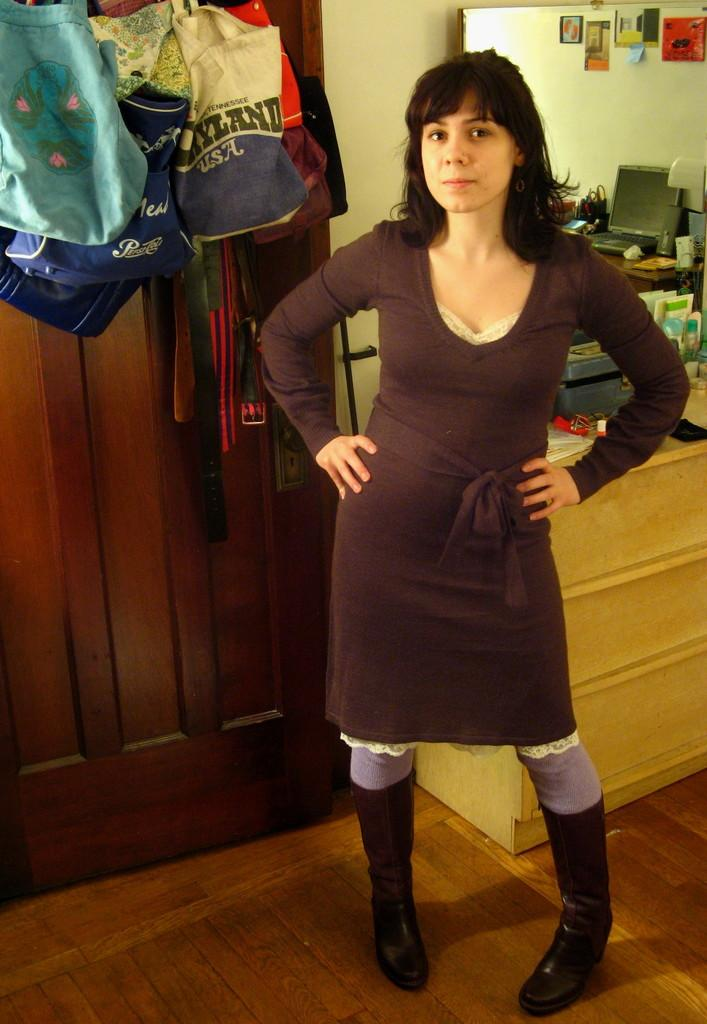Provide a one-sentence caption for the provided image. A woman in a brown dress is standing with her hands on her hip and behind her is a blue and white bag with USA on it. 